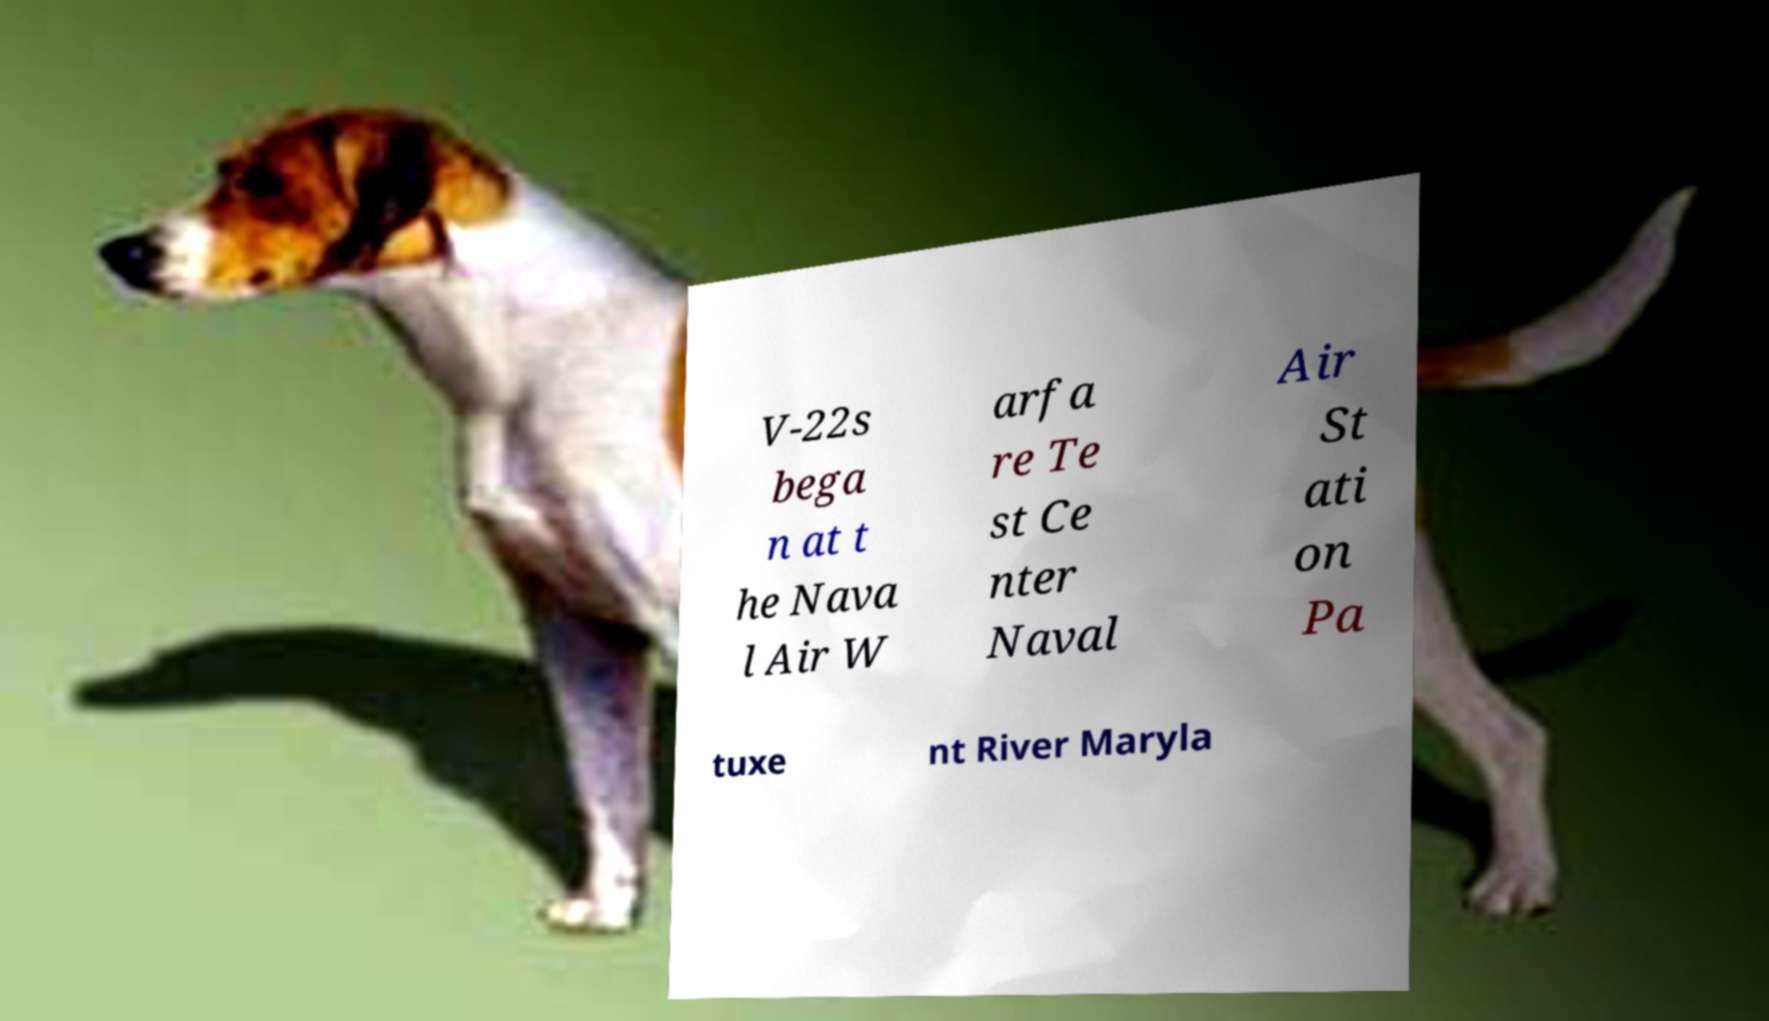For documentation purposes, I need the text within this image transcribed. Could you provide that? V-22s bega n at t he Nava l Air W arfa re Te st Ce nter Naval Air St ati on Pa tuxe nt River Maryla 